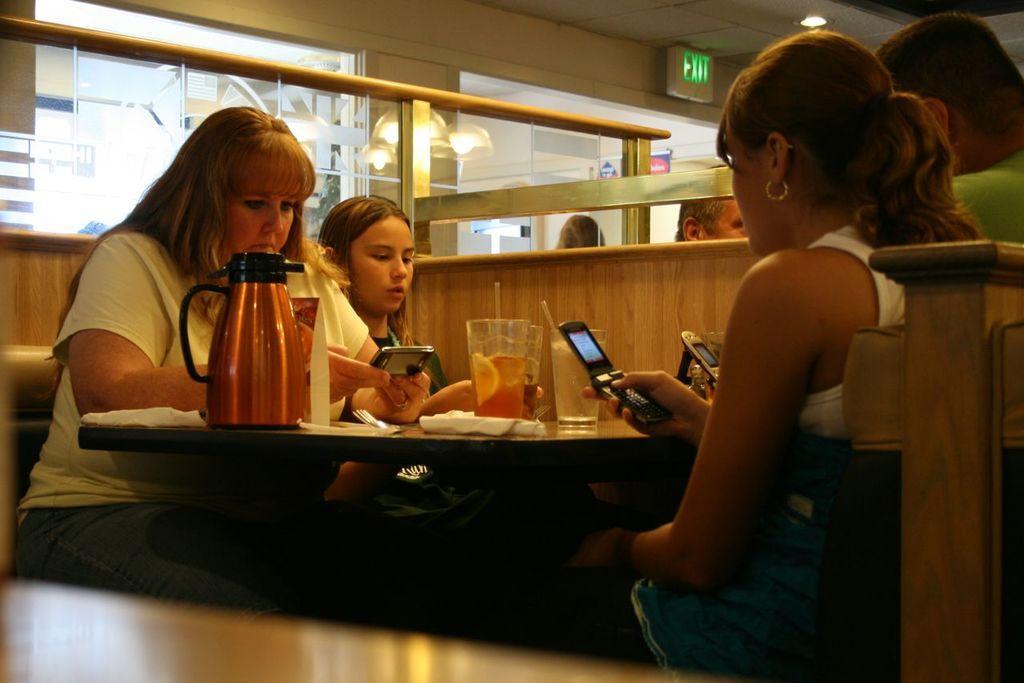Describe this image in one or two sentences. There are few girls sitting around the table and operating their mobile phones. There is a glass and tissues along with spoons on table. Above them there is a light wall and a exit board. 